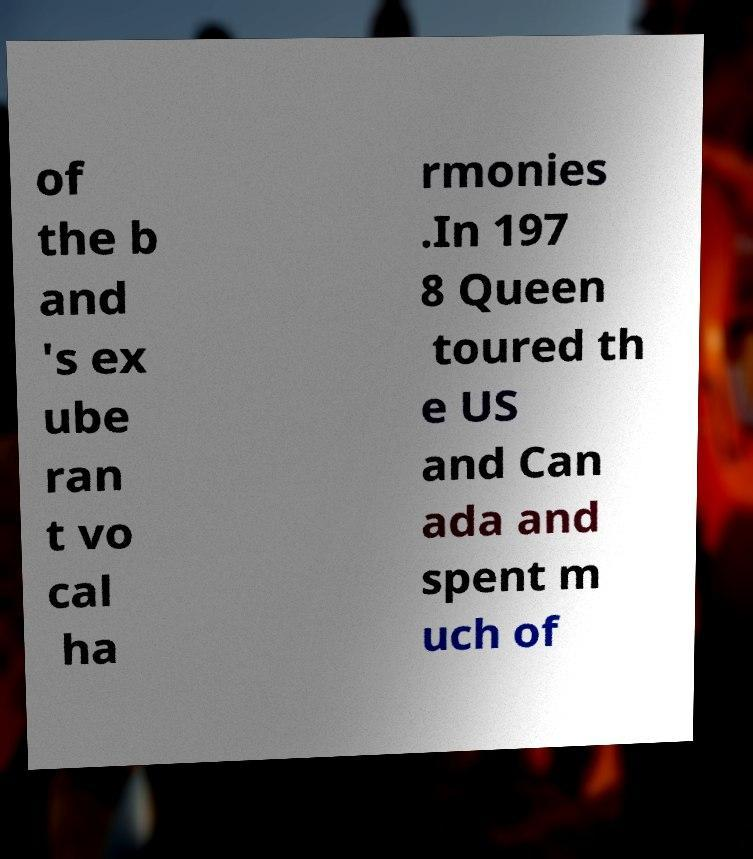Can you read and provide the text displayed in the image?This photo seems to have some interesting text. Can you extract and type it out for me? of the b and 's ex ube ran t vo cal ha rmonies .In 197 8 Queen toured th e US and Can ada and spent m uch of 